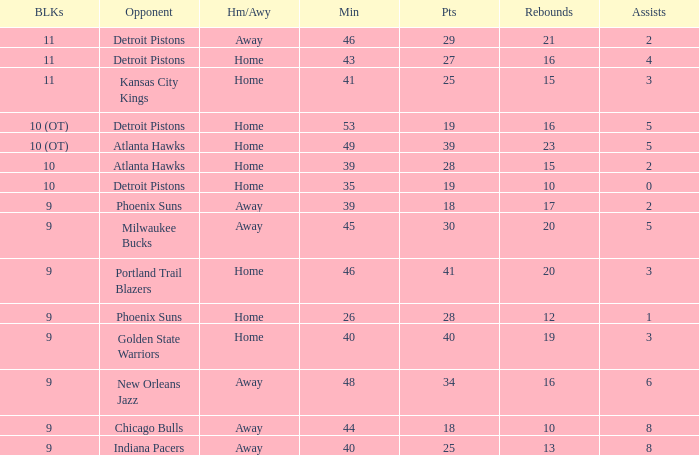How many points were there when there were less than 16 rebounds and 5 assists? 0.0. 